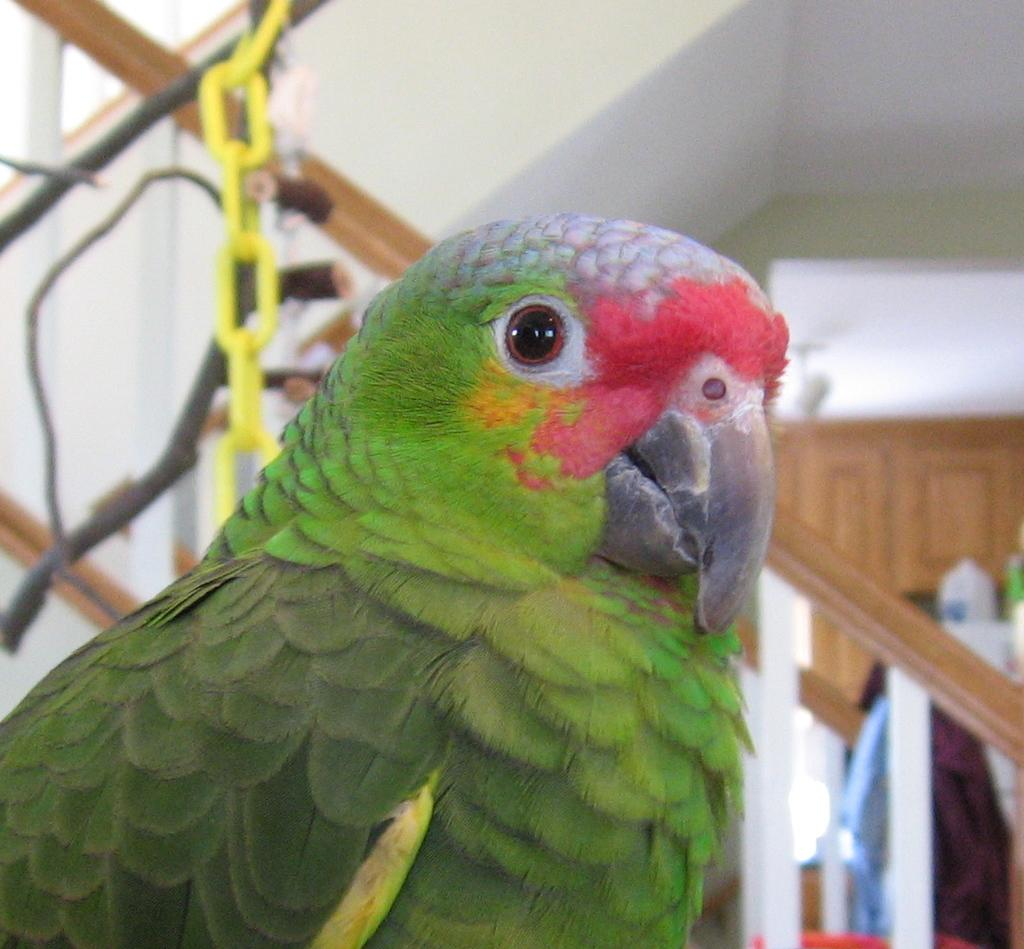What type of animal is in the image? There is a green parrot in the image. Where is the parrot located in the image? The parrot is in the front of the image. What other object can be seen behind the parrot? There is a staircase behind the parrot. What is on the wall in the background of the image? There is a cupboard on the wall in the background of the image. What sound does the parrot make while engaging in its favorite hobby in the image? There is no information about the parrot's favorite hobby or the sound it makes in the image. 